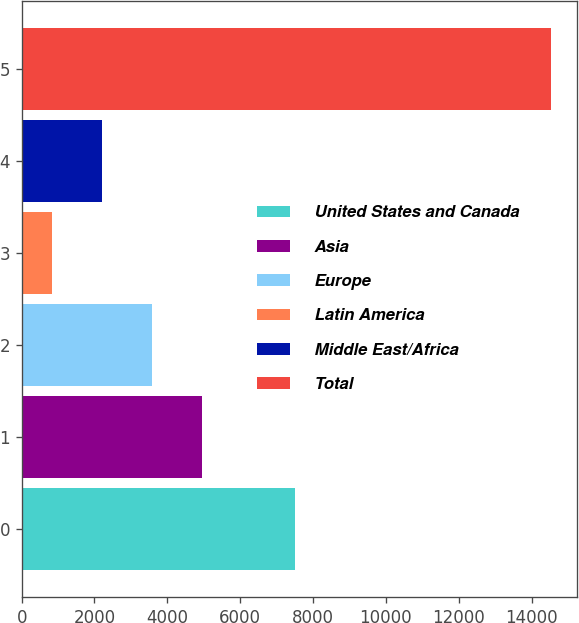<chart> <loc_0><loc_0><loc_500><loc_500><bar_chart><fcel>United States and Canada<fcel>Asia<fcel>Europe<fcel>Latin America<fcel>Middle East/Africa<fcel>Total<nl><fcel>7505<fcel>4940.4<fcel>3571.6<fcel>834<fcel>2202.8<fcel>14522<nl></chart> 